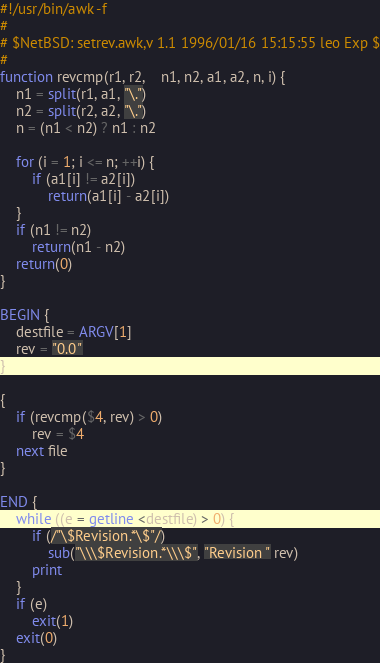<code> <loc_0><loc_0><loc_500><loc_500><_Awk_>#!/usr/bin/awk -f
#
# $NetBSD: setrev.awk,v 1.1 1996/01/16 15:15:55 leo Exp $
#
function revcmp(r1, r2,    n1, n2, a1, a2, n, i) {
	n1 = split(r1, a1, "\.")
	n2 = split(r2, a2, "\.")
	n = (n1 < n2) ? n1 : n2

	for (i = 1; i <= n; ++i) {
		if (a1[i] != a2[i])
			return(a1[i] - a2[i])
	}
	if (n1 != n2)
		return(n1 - n2)
	return(0)
}

BEGIN {
	destfile = ARGV[1]
	rev = "0.0"
}

{
	if (revcmp($4, rev) > 0)
		rev = $4
	next file
}

END {
	while ((e = getline <destfile) > 0) {
		if (/"\$Revision.*\$"/)
			sub("\\\$Revision.*\\\$", "Revision " rev)
		print
	}
	if (e)
		exit(1)
	exit(0)
}
</code> 